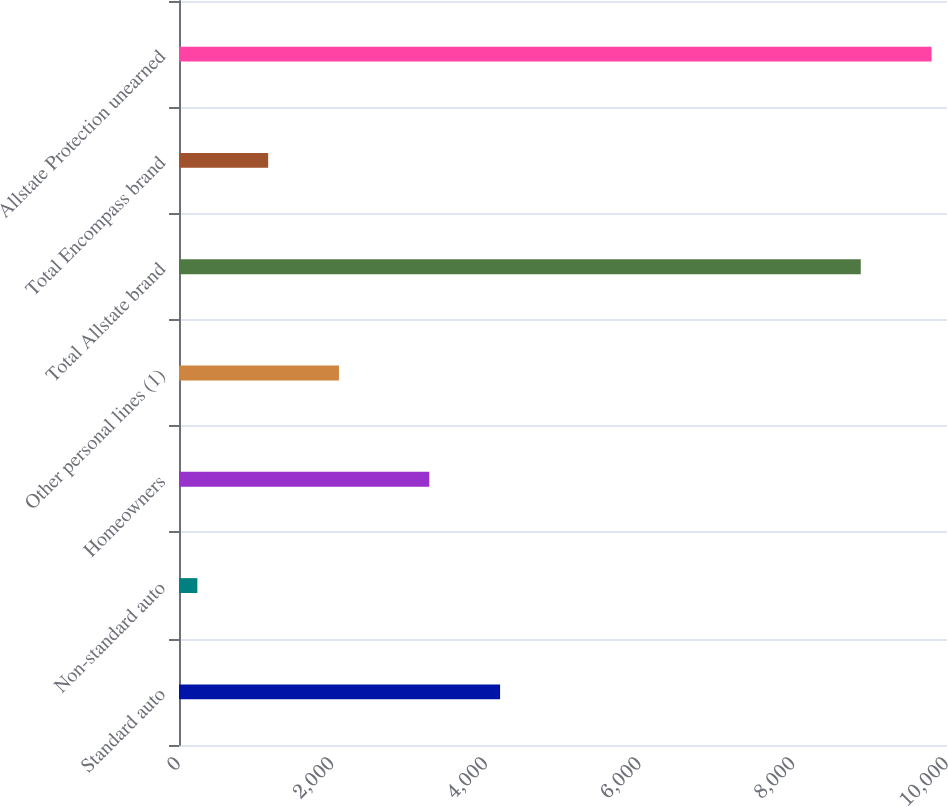Convert chart to OTSL. <chart><loc_0><loc_0><loc_500><loc_500><bar_chart><fcel>Standard auto<fcel>Non-standard auto<fcel>Homeowners<fcel>Other personal lines (1)<fcel>Total Allstate brand<fcel>Total Encompass brand<fcel>Allstate Protection unearned<nl><fcel>4180.9<fcel>239<fcel>3259<fcel>2082.8<fcel>8877<fcel>1160.9<fcel>9798.9<nl></chart> 